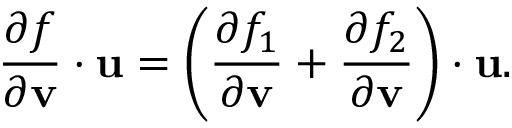Convert formula to latex. <formula><loc_0><loc_0><loc_500><loc_500>{ \frac { \partial f } { \partial v } } \cdot u = \left ( { \frac { \partial f _ { 1 } } { \partial v } } + { \frac { \partial f _ { 2 } } { \partial v } } \right ) \cdot u .</formula> 